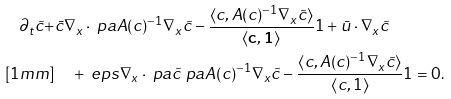Convert formula to latex. <formula><loc_0><loc_0><loc_500><loc_500>\partial _ { t } \tilde { c } + & \bar { c } \nabla _ { x } \cdot \ p a { A ( c ) ^ { - 1 } \nabla _ { x } \tilde { c } - \frac { \langle c , A ( c ) ^ { - 1 } \nabla _ { x } \tilde { c } \rangle } { \langle \mathbf { c } , \mathbf { 1 } \rangle } 1 } + \bar { u } \cdot \nabla _ { x } \tilde { c } \\ [ 1 m m ] & \quad + \ e p s \nabla _ { x } \cdot \ p a { \tilde { c } \ p a { A ( c ) ^ { - 1 } \nabla _ { x } \tilde { c } - \frac { \langle c , A ( c ) ^ { - 1 } \nabla _ { x } \tilde { c } \rangle } { \langle c , 1 \rangle } 1 } } = 0 .</formula> 